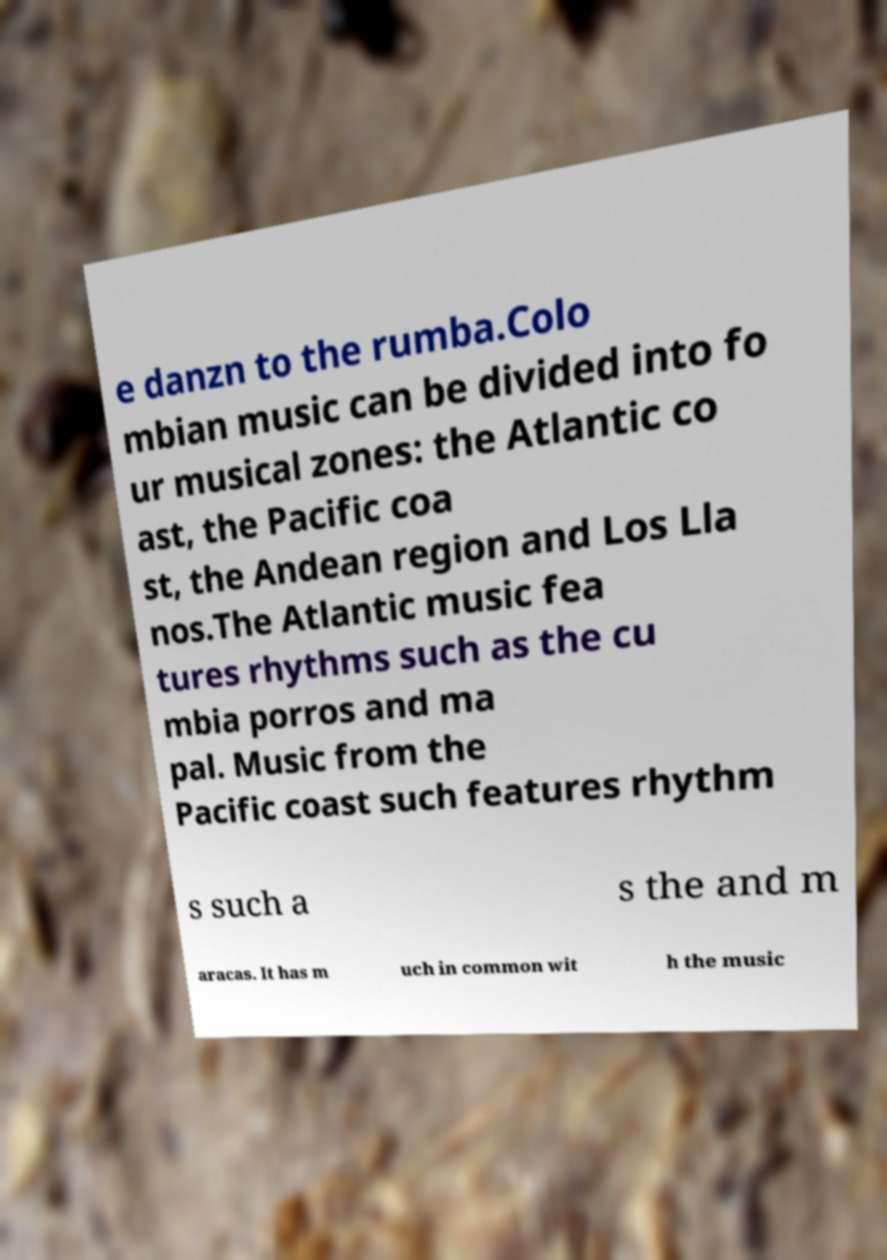For documentation purposes, I need the text within this image transcribed. Could you provide that? e danzn to the rumba.Colo mbian music can be divided into fo ur musical zones: the Atlantic co ast, the Pacific coa st, the Andean region and Los Lla nos.The Atlantic music fea tures rhythms such as the cu mbia porros and ma pal. Music from the Pacific coast such features rhythm s such a s the and m aracas. It has m uch in common wit h the music 